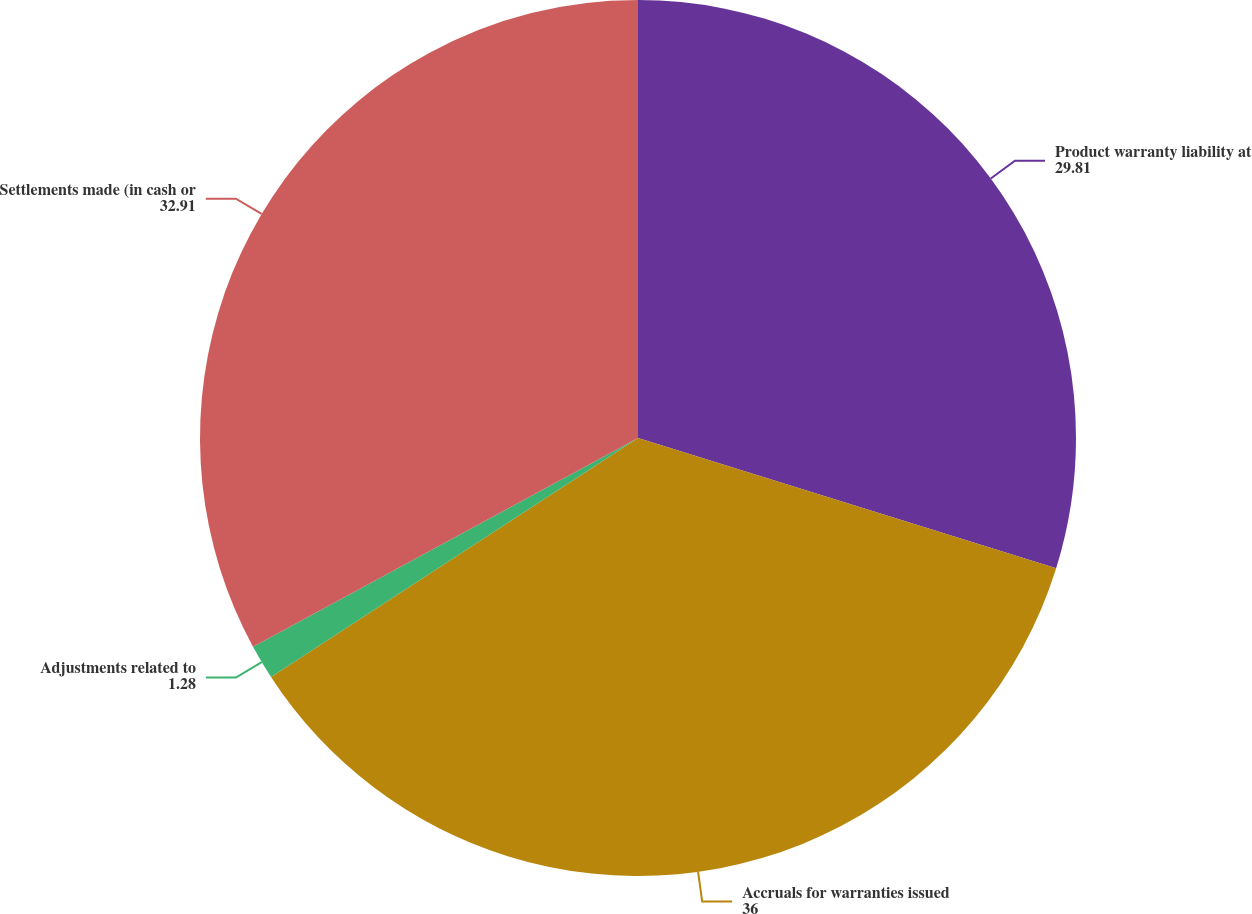<chart> <loc_0><loc_0><loc_500><loc_500><pie_chart><fcel>Product warranty liability at<fcel>Accruals for warranties issued<fcel>Adjustments related to<fcel>Settlements made (in cash or<nl><fcel>29.81%<fcel>36.0%<fcel>1.28%<fcel>32.91%<nl></chart> 